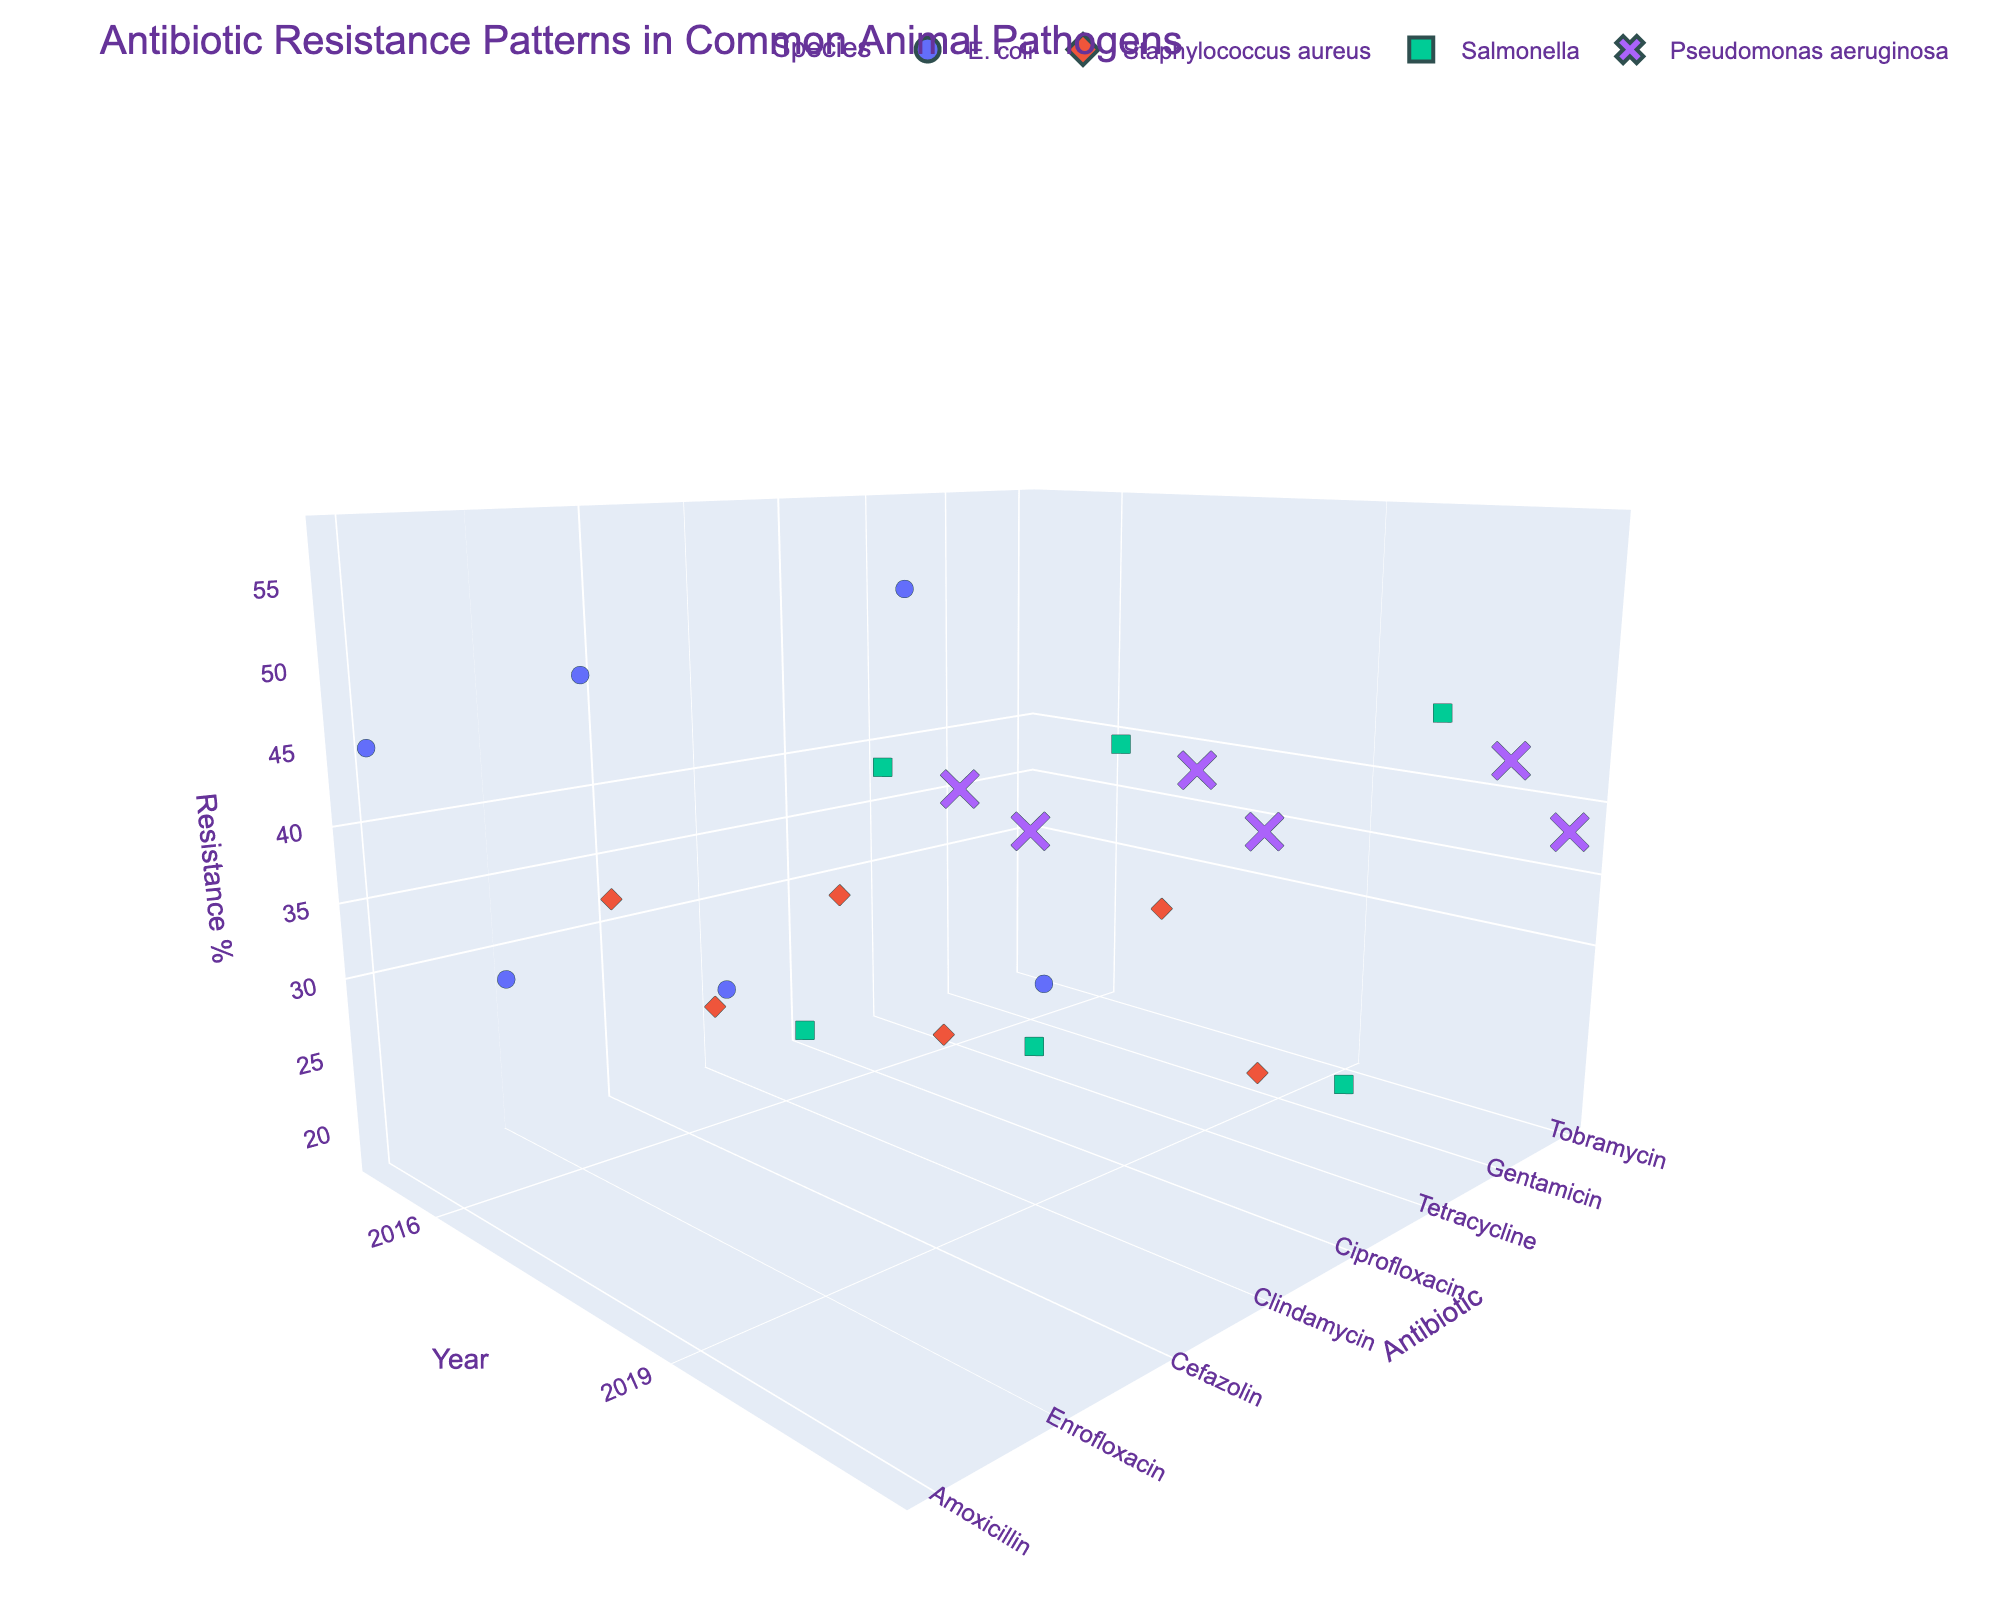What's the title of the figure? The title of the figure is usually positioned at the top of the chart. By looking at the top, we can identify the title.
Answer: Antibiotic Resistance Patterns in Common Animal Pathogens How many species are included in the data? By counting the unique symbols or colors in the scatter plot legend, which represent different species, we can determine the total number.
Answer: 4 Which antibiotic shows the highest resistance percentage for any species in 2021? To find this, look at the 2021 data points for each species and check the "Resistance Percentage" axis to see which point has the highest value.
Answer: Amoxicillin (E. coli) What is the trend for Ciprofloxacin resistance in Salmonella from 2015 to 2021? Observe the position of the Ciprofloxacin data points for Salmonella along the "Year" axis and track their movement along the "Resistance Percentage" axis.
Answer: Increasing Which species has the most consistent resistance percentage across all years for a single antibiotic? Compare the data points for each species and antibiotic combination across different years and see which combination shows the least variation in resistance percentages.
Answer: Staphylococcus aureus (Clindamycin) How does the resistance change for Enrofloxacin in E. coli from 2015 to 2021? Identify the data points for Enrofloxacin in E. coli, then observe their positions along the "Year" axis to track changes in the "Resistance Percentage".
Answer: Increases from 28% to 39% What is the average resistance percentage for Tetracycline in Salmonella over the years? Add the resistance percentages for Tetracycline in Salmonella across all years and divide by the number of data points (years).
Answer: (38 + 43 + 48) / 3 = 43% Which antibiotic has the lowest resistance percentage for Pseudomonas aeruginosa in 2015? Identify the data points for Pseudomonas aeruginosa in 2015 and compare their resistance percentages to find the lowest one.
Answer: Tobramycin In 2021, which species and antibiotic combination has a resistance percentage closest to 40%? Look at the 2021 data points and find the one where the resistance percentage is closest to 40%.
Answer: Staphylococcus aureus (Cefazolin) Overall, which species shows the highest increase in resistance percentage for any single antibiotic over the given years? Examine the change in resistance percentages for each species and antibiotic combination from 2015 to 2021, identifying the largest increase.
Answer: E. coli (Amoxicillin) 